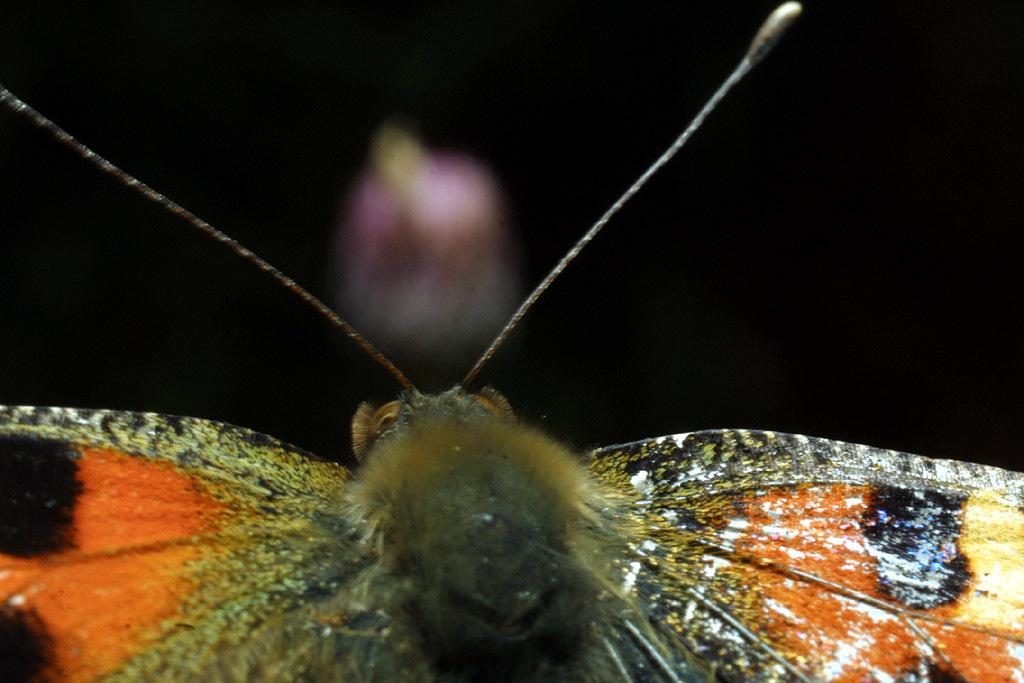What type of creature can be seen in the image? There is an insect in the image. What can be observed about the background of the image? The background of the image is dark. What type of skirt is the insect wearing in the image? There is no skirt present in the image, as insects do not wear clothing. 